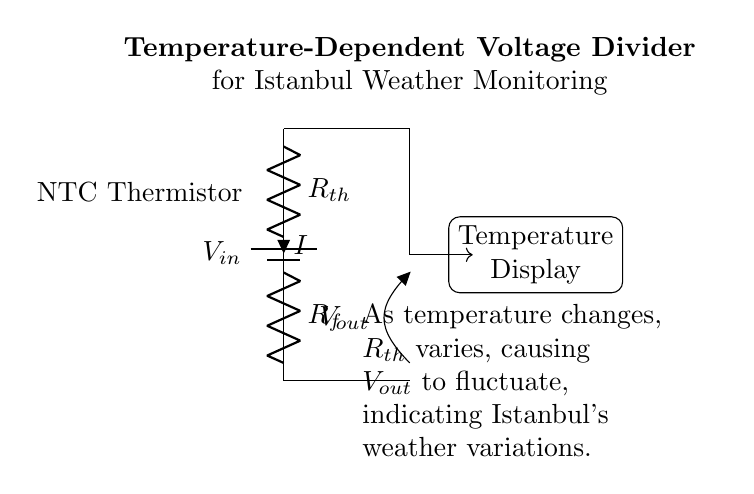What is the input voltage for the circuit? The input voltage is indicated as V_in which is the voltage provided by the battery at the top of the circuit.
Answer: V_in What type of thermistor is used in this circuit? The circuit diagram specifies that an NTC (Negative Temperature Coefficient) thermistor is used, which decreases resistance with an increase in temperature.
Answer: NTC What does the output voltage, V_out, represent in this circuit? V_out represents the voltage measured across the output terminals, which will vary based on the changing resistance of the thermistor as the temperature fluctuates.
Answer: Voltage indicating temperature Which component in the circuit acts as a temperature sensor? The temperature sensor component is the thermistor labeled R_th, which is designed to change resistance based on temperature variations.
Answer: R_th How does the thermistor's resistance affect V_out? As temperature rises, the NTC thermistor’s resistance decreases, causing the output voltage V_out to increase according to the voltage divider formula.
Answer: R_th decreases, V_out increases What component is used alongside the thermistor in the circuit? A fixed resistor labeled R_f is used in conjunction with the thermistor to form the voltage divider circuit that allows for temperature measurement.
Answer: R_f What is the purpose of the temperature display in this circuit? The temperature display receives the output voltage V_out to visually indicate the corresponding temperature based on the voltage changes caused by the thermistor.
Answer: Monitor temperature visually 